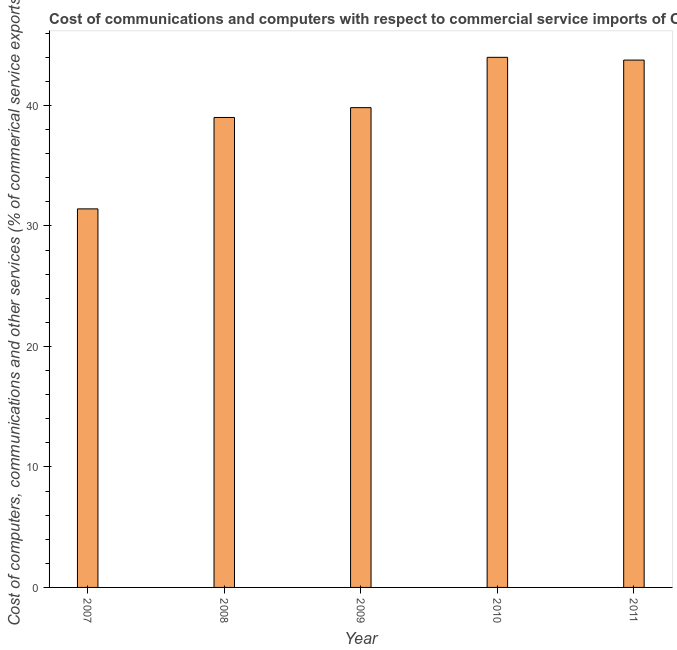Does the graph contain any zero values?
Provide a short and direct response. No. What is the title of the graph?
Your response must be concise. Cost of communications and computers with respect to commercial service imports of Other small states. What is the label or title of the X-axis?
Offer a very short reply. Year. What is the label or title of the Y-axis?
Give a very brief answer. Cost of computers, communications and other services (% of commerical service exports). What is the cost of communications in 2011?
Your answer should be very brief. 43.76. Across all years, what is the maximum cost of communications?
Provide a short and direct response. 43.99. Across all years, what is the minimum cost of communications?
Make the answer very short. 31.41. In which year was the cost of communications minimum?
Ensure brevity in your answer.  2007. What is the sum of the  computer and other services?
Provide a succinct answer. 197.98. What is the difference between the  computer and other services in 2008 and 2011?
Provide a short and direct response. -4.76. What is the average cost of communications per year?
Offer a terse response. 39.6. What is the median cost of communications?
Provide a short and direct response. 39.81. In how many years, is the cost of communications greater than 28 %?
Give a very brief answer. 5. What is the ratio of the  computer and other services in 2007 to that in 2008?
Your answer should be compact. 0.81. Is the difference between the cost of communications in 2007 and 2009 greater than the difference between any two years?
Your response must be concise. No. What is the difference between the highest and the second highest  computer and other services?
Keep it short and to the point. 0.23. What is the difference between the highest and the lowest cost of communications?
Provide a short and direct response. 12.58. In how many years, is the  computer and other services greater than the average  computer and other services taken over all years?
Offer a terse response. 3. How many bars are there?
Offer a very short reply. 5. Are all the bars in the graph horizontal?
Make the answer very short. No. What is the difference between two consecutive major ticks on the Y-axis?
Keep it short and to the point. 10. Are the values on the major ticks of Y-axis written in scientific E-notation?
Your answer should be very brief. No. What is the Cost of computers, communications and other services (% of commerical service exports) in 2007?
Your response must be concise. 31.41. What is the Cost of computers, communications and other services (% of commerical service exports) of 2008?
Make the answer very short. 39. What is the Cost of computers, communications and other services (% of commerical service exports) of 2009?
Your response must be concise. 39.81. What is the Cost of computers, communications and other services (% of commerical service exports) in 2010?
Provide a short and direct response. 43.99. What is the Cost of computers, communications and other services (% of commerical service exports) of 2011?
Your response must be concise. 43.76. What is the difference between the Cost of computers, communications and other services (% of commerical service exports) in 2007 and 2008?
Your response must be concise. -7.59. What is the difference between the Cost of computers, communications and other services (% of commerical service exports) in 2007 and 2009?
Your response must be concise. -8.4. What is the difference between the Cost of computers, communications and other services (% of commerical service exports) in 2007 and 2010?
Your response must be concise. -12.58. What is the difference between the Cost of computers, communications and other services (% of commerical service exports) in 2007 and 2011?
Offer a very short reply. -12.35. What is the difference between the Cost of computers, communications and other services (% of commerical service exports) in 2008 and 2009?
Give a very brief answer. -0.81. What is the difference between the Cost of computers, communications and other services (% of commerical service exports) in 2008 and 2010?
Offer a very short reply. -4.99. What is the difference between the Cost of computers, communications and other services (% of commerical service exports) in 2008 and 2011?
Your response must be concise. -4.76. What is the difference between the Cost of computers, communications and other services (% of commerical service exports) in 2009 and 2010?
Offer a terse response. -4.18. What is the difference between the Cost of computers, communications and other services (% of commerical service exports) in 2009 and 2011?
Your answer should be very brief. -3.95. What is the difference between the Cost of computers, communications and other services (% of commerical service exports) in 2010 and 2011?
Your answer should be compact. 0.23. What is the ratio of the Cost of computers, communications and other services (% of commerical service exports) in 2007 to that in 2008?
Keep it short and to the point. 0.81. What is the ratio of the Cost of computers, communications and other services (% of commerical service exports) in 2007 to that in 2009?
Provide a succinct answer. 0.79. What is the ratio of the Cost of computers, communications and other services (% of commerical service exports) in 2007 to that in 2010?
Offer a terse response. 0.71. What is the ratio of the Cost of computers, communications and other services (% of commerical service exports) in 2007 to that in 2011?
Make the answer very short. 0.72. What is the ratio of the Cost of computers, communications and other services (% of commerical service exports) in 2008 to that in 2009?
Your response must be concise. 0.98. What is the ratio of the Cost of computers, communications and other services (% of commerical service exports) in 2008 to that in 2010?
Make the answer very short. 0.89. What is the ratio of the Cost of computers, communications and other services (% of commerical service exports) in 2008 to that in 2011?
Your answer should be very brief. 0.89. What is the ratio of the Cost of computers, communications and other services (% of commerical service exports) in 2009 to that in 2010?
Keep it short and to the point. 0.91. What is the ratio of the Cost of computers, communications and other services (% of commerical service exports) in 2009 to that in 2011?
Offer a terse response. 0.91. What is the ratio of the Cost of computers, communications and other services (% of commerical service exports) in 2010 to that in 2011?
Your answer should be very brief. 1. 